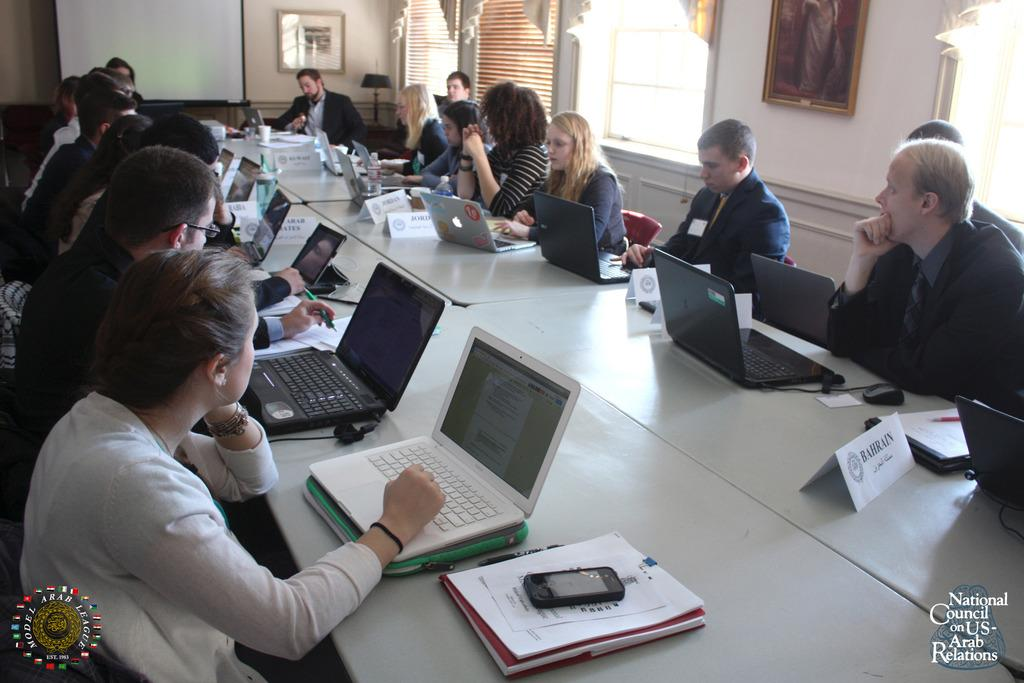<image>
Summarize the visual content of the image. A meeting takes place at the National Council on US-Arab Relations. 